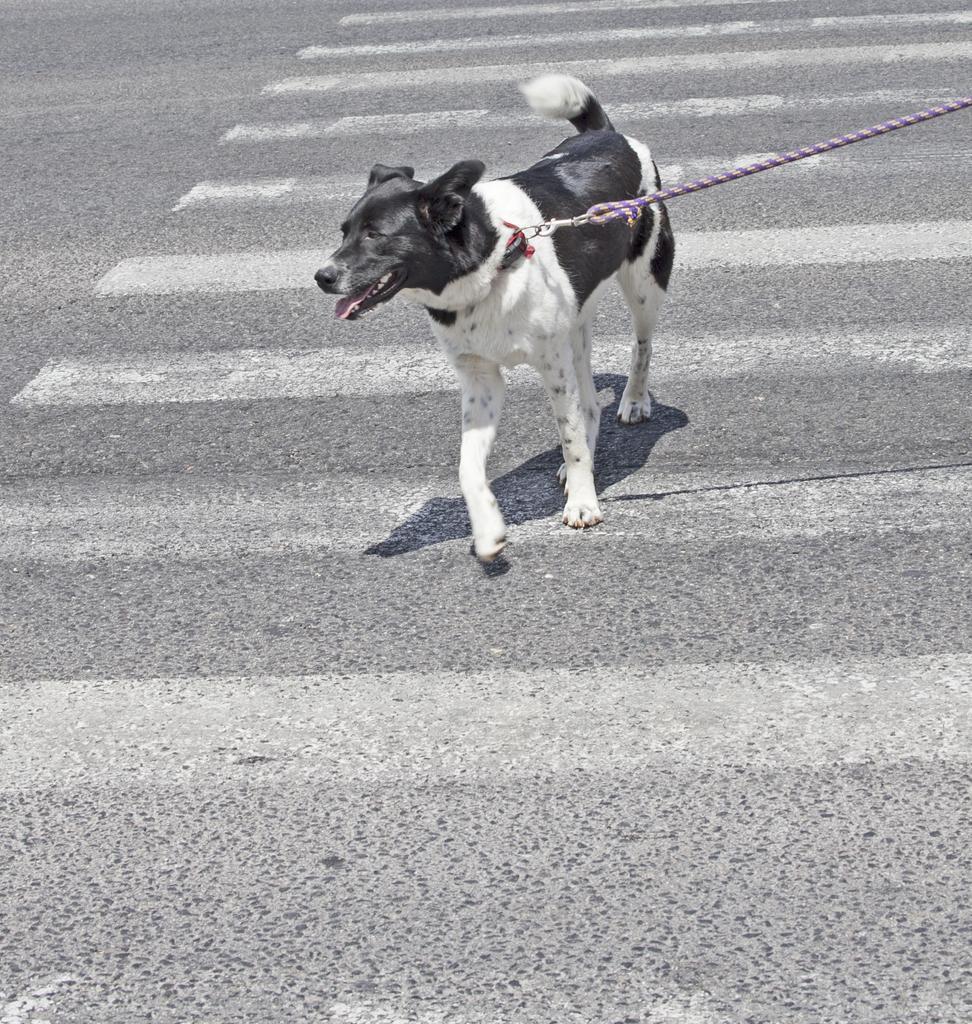Describe this image in one or two sentences. In this picture, we see a dog with white and black color is walking on the road. The leash in purple color is tied around its neck. At the bottom of the picture, we see the road and the zebra crossing. 